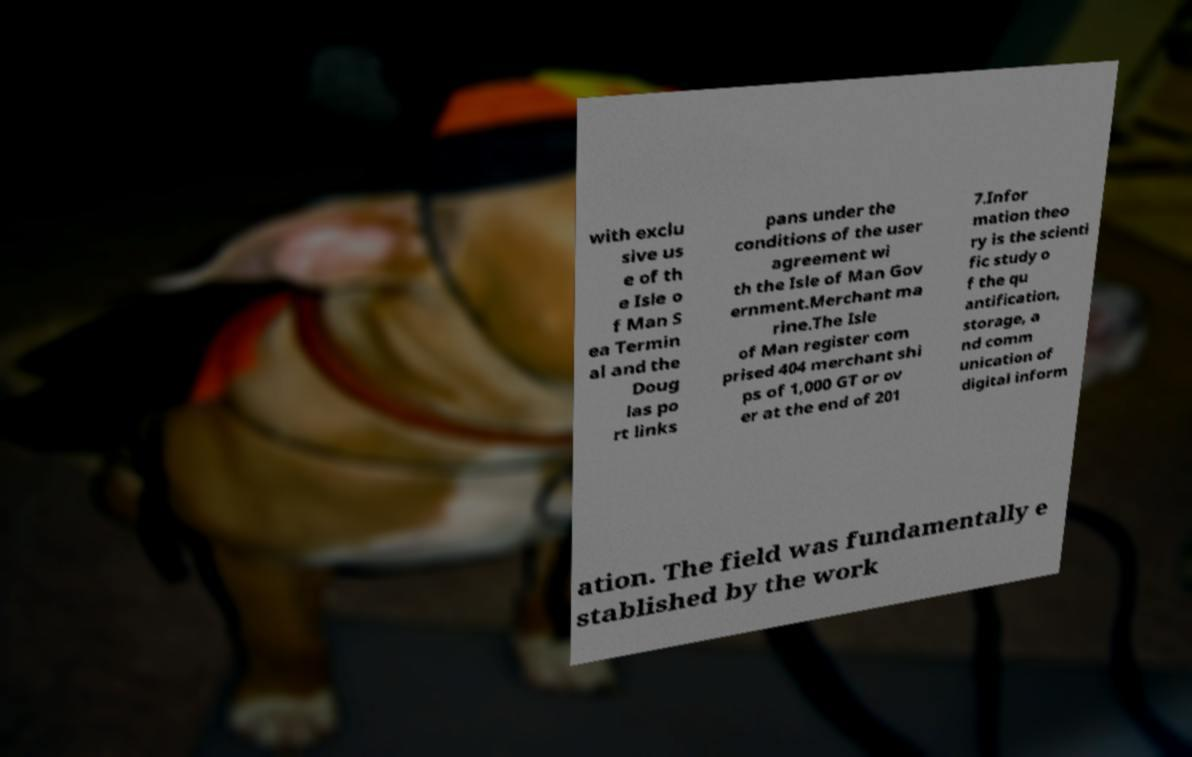Could you extract and type out the text from this image? with exclu sive us e of th e Isle o f Man S ea Termin al and the Doug las po rt links pans under the conditions of the user agreement wi th the Isle of Man Gov ernment.Merchant ma rine.The Isle of Man register com prised 404 merchant shi ps of 1,000 GT or ov er at the end of 201 7.Infor mation theo ry is the scienti fic study o f the qu antification, storage, a nd comm unication of digital inform ation. The field was fundamentally e stablished by the work 